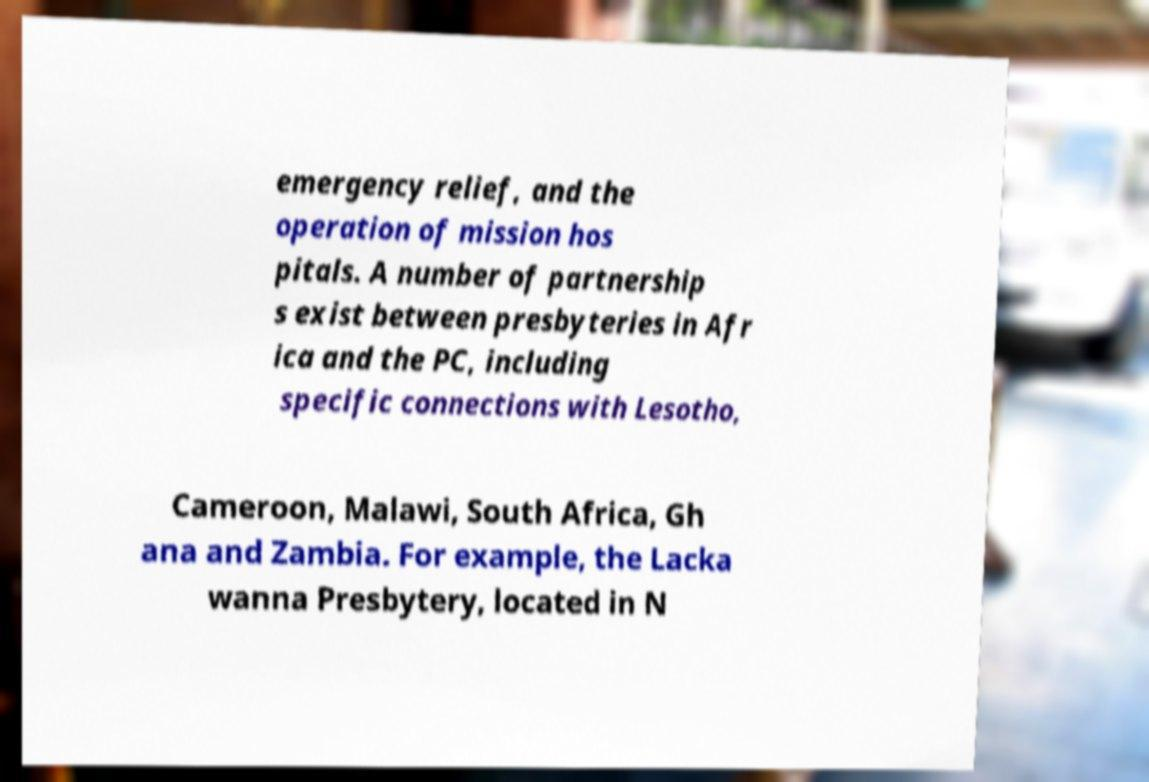Can you accurately transcribe the text from the provided image for me? emergency relief, and the operation of mission hos pitals. A number of partnership s exist between presbyteries in Afr ica and the PC, including specific connections with Lesotho, Cameroon, Malawi, South Africa, Gh ana and Zambia. For example, the Lacka wanna Presbytery, located in N 